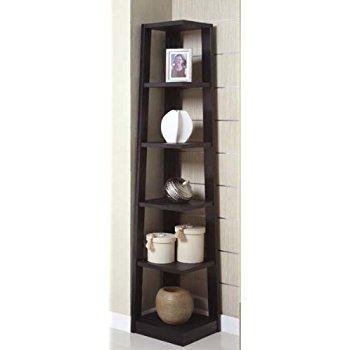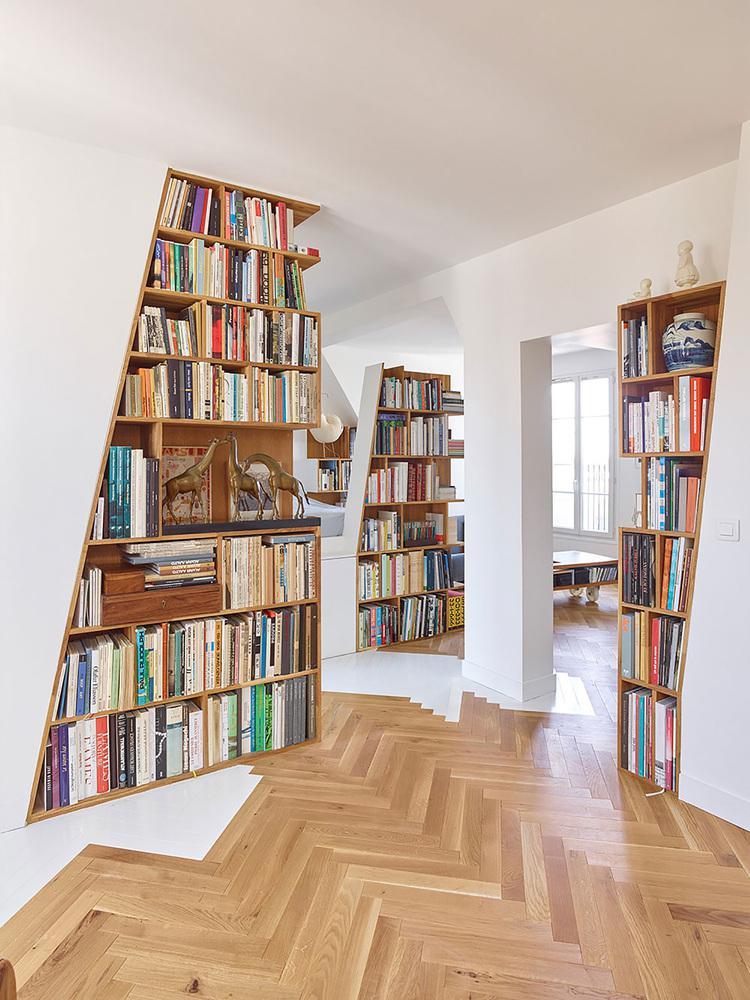The first image is the image on the left, the second image is the image on the right. Given the left and right images, does the statement "An image features a black upright corner shelf unit with items displayed on some of the shelves." hold true? Answer yes or no. Yes. The first image is the image on the left, the second image is the image on the right. Evaluate the accuracy of this statement regarding the images: "In one image the shelves are black.". Is it true? Answer yes or no. Yes. 